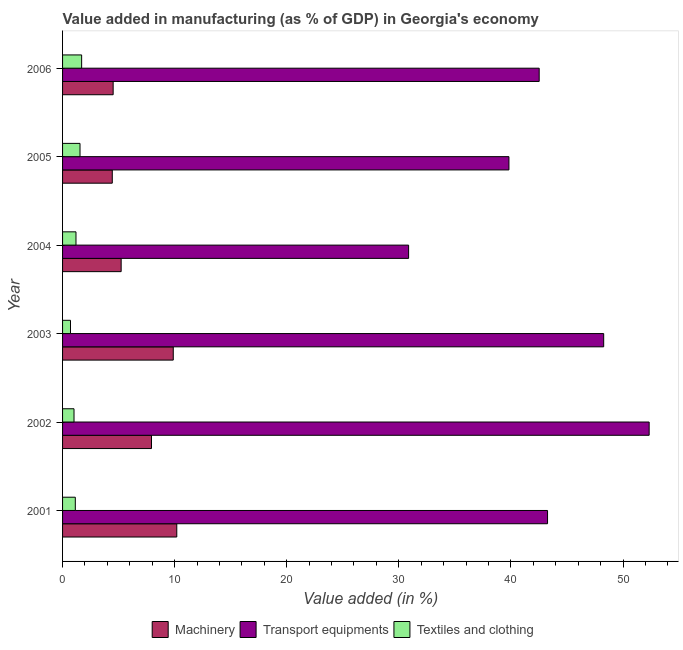How many different coloured bars are there?
Offer a very short reply. 3. How many groups of bars are there?
Your answer should be very brief. 6. Are the number of bars per tick equal to the number of legend labels?
Offer a terse response. Yes. Are the number of bars on each tick of the Y-axis equal?
Offer a terse response. Yes. What is the label of the 2nd group of bars from the top?
Ensure brevity in your answer.  2005. In how many cases, is the number of bars for a given year not equal to the number of legend labels?
Your answer should be very brief. 0. What is the value added in manufacturing textile and clothing in 2006?
Give a very brief answer. 1.7. Across all years, what is the maximum value added in manufacturing textile and clothing?
Ensure brevity in your answer.  1.7. Across all years, what is the minimum value added in manufacturing machinery?
Make the answer very short. 4.44. What is the total value added in manufacturing textile and clothing in the graph?
Provide a short and direct response. 7.32. What is the difference between the value added in manufacturing machinery in 2005 and that in 2006?
Give a very brief answer. -0.08. What is the difference between the value added in manufacturing textile and clothing in 2004 and the value added in manufacturing machinery in 2005?
Provide a short and direct response. -3.24. What is the average value added in manufacturing machinery per year?
Provide a short and direct response. 7.03. In the year 2003, what is the difference between the value added in manufacturing textile and clothing and value added in manufacturing transport equipments?
Provide a short and direct response. -47.57. What is the ratio of the value added in manufacturing textile and clothing in 2001 to that in 2003?
Offer a terse response. 1.61. What is the difference between the highest and the second highest value added in manufacturing transport equipments?
Your response must be concise. 4.06. What is the difference between the highest and the lowest value added in manufacturing transport equipments?
Your response must be concise. 21.46. In how many years, is the value added in manufacturing transport equipments greater than the average value added in manufacturing transport equipments taken over all years?
Ensure brevity in your answer.  3. Is the sum of the value added in manufacturing machinery in 2003 and 2004 greater than the maximum value added in manufacturing transport equipments across all years?
Your answer should be very brief. No. What does the 2nd bar from the top in 2004 represents?
Keep it short and to the point. Transport equipments. What does the 3rd bar from the bottom in 2005 represents?
Give a very brief answer. Textiles and clothing. How many years are there in the graph?
Keep it short and to the point. 6. Does the graph contain any zero values?
Keep it short and to the point. No. Does the graph contain grids?
Keep it short and to the point. No. Where does the legend appear in the graph?
Give a very brief answer. Bottom center. How are the legend labels stacked?
Provide a short and direct response. Horizontal. What is the title of the graph?
Keep it short and to the point. Value added in manufacturing (as % of GDP) in Georgia's economy. Does "Grants" appear as one of the legend labels in the graph?
Ensure brevity in your answer.  No. What is the label or title of the X-axis?
Make the answer very short. Value added (in %). What is the Value added (in %) in Machinery in 2001?
Ensure brevity in your answer.  10.19. What is the Value added (in %) of Transport equipments in 2001?
Make the answer very short. 43.27. What is the Value added (in %) in Textiles and clothing in 2001?
Offer a very short reply. 1.14. What is the Value added (in %) in Machinery in 2002?
Offer a very short reply. 7.93. What is the Value added (in %) of Transport equipments in 2002?
Offer a very short reply. 52.33. What is the Value added (in %) of Textiles and clothing in 2002?
Provide a short and direct response. 1.02. What is the Value added (in %) of Machinery in 2003?
Offer a terse response. 9.88. What is the Value added (in %) in Transport equipments in 2003?
Ensure brevity in your answer.  48.28. What is the Value added (in %) of Textiles and clothing in 2003?
Keep it short and to the point. 0.71. What is the Value added (in %) in Machinery in 2004?
Make the answer very short. 5.23. What is the Value added (in %) of Transport equipments in 2004?
Your answer should be very brief. 30.87. What is the Value added (in %) in Textiles and clothing in 2004?
Make the answer very short. 1.2. What is the Value added (in %) of Machinery in 2005?
Provide a short and direct response. 4.44. What is the Value added (in %) in Transport equipments in 2005?
Your response must be concise. 39.82. What is the Value added (in %) in Textiles and clothing in 2005?
Your answer should be very brief. 1.56. What is the Value added (in %) in Machinery in 2006?
Offer a terse response. 4.51. What is the Value added (in %) of Transport equipments in 2006?
Offer a very short reply. 42.52. What is the Value added (in %) of Textiles and clothing in 2006?
Give a very brief answer. 1.7. Across all years, what is the maximum Value added (in %) of Machinery?
Offer a very short reply. 10.19. Across all years, what is the maximum Value added (in %) of Transport equipments?
Ensure brevity in your answer.  52.33. Across all years, what is the maximum Value added (in %) in Textiles and clothing?
Your response must be concise. 1.7. Across all years, what is the minimum Value added (in %) of Machinery?
Your answer should be compact. 4.44. Across all years, what is the minimum Value added (in %) in Transport equipments?
Provide a short and direct response. 30.87. Across all years, what is the minimum Value added (in %) of Textiles and clothing?
Ensure brevity in your answer.  0.71. What is the total Value added (in %) in Machinery in the graph?
Give a very brief answer. 42.18. What is the total Value added (in %) of Transport equipments in the graph?
Provide a short and direct response. 257.1. What is the total Value added (in %) of Textiles and clothing in the graph?
Ensure brevity in your answer.  7.32. What is the difference between the Value added (in %) in Machinery in 2001 and that in 2002?
Keep it short and to the point. 2.26. What is the difference between the Value added (in %) of Transport equipments in 2001 and that in 2002?
Give a very brief answer. -9.07. What is the difference between the Value added (in %) in Textiles and clothing in 2001 and that in 2002?
Make the answer very short. 0.12. What is the difference between the Value added (in %) of Machinery in 2001 and that in 2003?
Ensure brevity in your answer.  0.31. What is the difference between the Value added (in %) of Transport equipments in 2001 and that in 2003?
Give a very brief answer. -5.01. What is the difference between the Value added (in %) of Textiles and clothing in 2001 and that in 2003?
Offer a very short reply. 0.43. What is the difference between the Value added (in %) in Machinery in 2001 and that in 2004?
Keep it short and to the point. 4.96. What is the difference between the Value added (in %) in Transport equipments in 2001 and that in 2004?
Ensure brevity in your answer.  12.4. What is the difference between the Value added (in %) of Textiles and clothing in 2001 and that in 2004?
Offer a terse response. -0.06. What is the difference between the Value added (in %) of Machinery in 2001 and that in 2005?
Offer a terse response. 5.75. What is the difference between the Value added (in %) of Transport equipments in 2001 and that in 2005?
Keep it short and to the point. 3.44. What is the difference between the Value added (in %) of Textiles and clothing in 2001 and that in 2005?
Keep it short and to the point. -0.42. What is the difference between the Value added (in %) of Machinery in 2001 and that in 2006?
Make the answer very short. 5.68. What is the difference between the Value added (in %) of Transport equipments in 2001 and that in 2006?
Ensure brevity in your answer.  0.75. What is the difference between the Value added (in %) in Textiles and clothing in 2001 and that in 2006?
Provide a short and direct response. -0.56. What is the difference between the Value added (in %) of Machinery in 2002 and that in 2003?
Give a very brief answer. -1.94. What is the difference between the Value added (in %) in Transport equipments in 2002 and that in 2003?
Provide a short and direct response. 4.06. What is the difference between the Value added (in %) in Textiles and clothing in 2002 and that in 2003?
Your answer should be very brief. 0.31. What is the difference between the Value added (in %) of Machinery in 2002 and that in 2004?
Your answer should be very brief. 2.71. What is the difference between the Value added (in %) in Transport equipments in 2002 and that in 2004?
Your answer should be compact. 21.46. What is the difference between the Value added (in %) in Textiles and clothing in 2002 and that in 2004?
Keep it short and to the point. -0.18. What is the difference between the Value added (in %) of Machinery in 2002 and that in 2005?
Give a very brief answer. 3.5. What is the difference between the Value added (in %) in Transport equipments in 2002 and that in 2005?
Your answer should be very brief. 12.51. What is the difference between the Value added (in %) in Textiles and clothing in 2002 and that in 2005?
Make the answer very short. -0.54. What is the difference between the Value added (in %) in Machinery in 2002 and that in 2006?
Your answer should be compact. 3.42. What is the difference between the Value added (in %) of Transport equipments in 2002 and that in 2006?
Offer a very short reply. 9.81. What is the difference between the Value added (in %) of Textiles and clothing in 2002 and that in 2006?
Offer a very short reply. -0.68. What is the difference between the Value added (in %) of Machinery in 2003 and that in 2004?
Keep it short and to the point. 4.65. What is the difference between the Value added (in %) in Transport equipments in 2003 and that in 2004?
Offer a terse response. 17.4. What is the difference between the Value added (in %) in Textiles and clothing in 2003 and that in 2004?
Offer a terse response. -0.49. What is the difference between the Value added (in %) in Machinery in 2003 and that in 2005?
Ensure brevity in your answer.  5.44. What is the difference between the Value added (in %) in Transport equipments in 2003 and that in 2005?
Offer a very short reply. 8.45. What is the difference between the Value added (in %) of Textiles and clothing in 2003 and that in 2005?
Offer a terse response. -0.85. What is the difference between the Value added (in %) of Machinery in 2003 and that in 2006?
Keep it short and to the point. 5.36. What is the difference between the Value added (in %) in Transport equipments in 2003 and that in 2006?
Your answer should be very brief. 5.75. What is the difference between the Value added (in %) in Textiles and clothing in 2003 and that in 2006?
Your answer should be very brief. -0.99. What is the difference between the Value added (in %) in Machinery in 2004 and that in 2005?
Keep it short and to the point. 0.79. What is the difference between the Value added (in %) in Transport equipments in 2004 and that in 2005?
Ensure brevity in your answer.  -8.95. What is the difference between the Value added (in %) in Textiles and clothing in 2004 and that in 2005?
Offer a terse response. -0.36. What is the difference between the Value added (in %) in Machinery in 2004 and that in 2006?
Provide a succinct answer. 0.71. What is the difference between the Value added (in %) in Transport equipments in 2004 and that in 2006?
Keep it short and to the point. -11.65. What is the difference between the Value added (in %) of Textiles and clothing in 2004 and that in 2006?
Provide a succinct answer. -0.51. What is the difference between the Value added (in %) of Machinery in 2005 and that in 2006?
Provide a succinct answer. -0.08. What is the difference between the Value added (in %) of Transport equipments in 2005 and that in 2006?
Give a very brief answer. -2.7. What is the difference between the Value added (in %) of Textiles and clothing in 2005 and that in 2006?
Provide a succinct answer. -0.15. What is the difference between the Value added (in %) in Machinery in 2001 and the Value added (in %) in Transport equipments in 2002?
Keep it short and to the point. -42.14. What is the difference between the Value added (in %) of Machinery in 2001 and the Value added (in %) of Textiles and clothing in 2002?
Provide a succinct answer. 9.17. What is the difference between the Value added (in %) of Transport equipments in 2001 and the Value added (in %) of Textiles and clothing in 2002?
Make the answer very short. 42.25. What is the difference between the Value added (in %) of Machinery in 2001 and the Value added (in %) of Transport equipments in 2003?
Keep it short and to the point. -38.09. What is the difference between the Value added (in %) of Machinery in 2001 and the Value added (in %) of Textiles and clothing in 2003?
Keep it short and to the point. 9.48. What is the difference between the Value added (in %) of Transport equipments in 2001 and the Value added (in %) of Textiles and clothing in 2003?
Your answer should be very brief. 42.56. What is the difference between the Value added (in %) of Machinery in 2001 and the Value added (in %) of Transport equipments in 2004?
Make the answer very short. -20.68. What is the difference between the Value added (in %) in Machinery in 2001 and the Value added (in %) in Textiles and clothing in 2004?
Give a very brief answer. 8.99. What is the difference between the Value added (in %) of Transport equipments in 2001 and the Value added (in %) of Textiles and clothing in 2004?
Provide a succinct answer. 42.07. What is the difference between the Value added (in %) in Machinery in 2001 and the Value added (in %) in Transport equipments in 2005?
Provide a short and direct response. -29.63. What is the difference between the Value added (in %) of Machinery in 2001 and the Value added (in %) of Textiles and clothing in 2005?
Give a very brief answer. 8.63. What is the difference between the Value added (in %) in Transport equipments in 2001 and the Value added (in %) in Textiles and clothing in 2005?
Your answer should be compact. 41.71. What is the difference between the Value added (in %) of Machinery in 2001 and the Value added (in %) of Transport equipments in 2006?
Your answer should be very brief. -32.33. What is the difference between the Value added (in %) of Machinery in 2001 and the Value added (in %) of Textiles and clothing in 2006?
Your response must be concise. 8.49. What is the difference between the Value added (in %) of Transport equipments in 2001 and the Value added (in %) of Textiles and clothing in 2006?
Your answer should be very brief. 41.57. What is the difference between the Value added (in %) in Machinery in 2002 and the Value added (in %) in Transport equipments in 2003?
Your answer should be very brief. -40.34. What is the difference between the Value added (in %) in Machinery in 2002 and the Value added (in %) in Textiles and clothing in 2003?
Offer a very short reply. 7.23. What is the difference between the Value added (in %) in Transport equipments in 2002 and the Value added (in %) in Textiles and clothing in 2003?
Provide a short and direct response. 51.63. What is the difference between the Value added (in %) in Machinery in 2002 and the Value added (in %) in Transport equipments in 2004?
Make the answer very short. -22.94. What is the difference between the Value added (in %) in Machinery in 2002 and the Value added (in %) in Textiles and clothing in 2004?
Make the answer very short. 6.74. What is the difference between the Value added (in %) in Transport equipments in 2002 and the Value added (in %) in Textiles and clothing in 2004?
Your response must be concise. 51.14. What is the difference between the Value added (in %) of Machinery in 2002 and the Value added (in %) of Transport equipments in 2005?
Your response must be concise. -31.89. What is the difference between the Value added (in %) of Machinery in 2002 and the Value added (in %) of Textiles and clothing in 2005?
Your answer should be compact. 6.38. What is the difference between the Value added (in %) in Transport equipments in 2002 and the Value added (in %) in Textiles and clothing in 2005?
Offer a terse response. 50.78. What is the difference between the Value added (in %) in Machinery in 2002 and the Value added (in %) in Transport equipments in 2006?
Offer a terse response. -34.59. What is the difference between the Value added (in %) of Machinery in 2002 and the Value added (in %) of Textiles and clothing in 2006?
Provide a succinct answer. 6.23. What is the difference between the Value added (in %) of Transport equipments in 2002 and the Value added (in %) of Textiles and clothing in 2006?
Offer a terse response. 50.63. What is the difference between the Value added (in %) in Machinery in 2003 and the Value added (in %) in Transport equipments in 2004?
Your answer should be compact. -21. What is the difference between the Value added (in %) in Machinery in 2003 and the Value added (in %) in Textiles and clothing in 2004?
Your answer should be very brief. 8.68. What is the difference between the Value added (in %) in Transport equipments in 2003 and the Value added (in %) in Textiles and clothing in 2004?
Provide a short and direct response. 47.08. What is the difference between the Value added (in %) in Machinery in 2003 and the Value added (in %) in Transport equipments in 2005?
Offer a very short reply. -29.95. What is the difference between the Value added (in %) of Machinery in 2003 and the Value added (in %) of Textiles and clothing in 2005?
Your answer should be compact. 8.32. What is the difference between the Value added (in %) in Transport equipments in 2003 and the Value added (in %) in Textiles and clothing in 2005?
Offer a terse response. 46.72. What is the difference between the Value added (in %) of Machinery in 2003 and the Value added (in %) of Transport equipments in 2006?
Provide a succinct answer. -32.65. What is the difference between the Value added (in %) in Machinery in 2003 and the Value added (in %) in Textiles and clothing in 2006?
Make the answer very short. 8.17. What is the difference between the Value added (in %) in Transport equipments in 2003 and the Value added (in %) in Textiles and clothing in 2006?
Offer a very short reply. 46.57. What is the difference between the Value added (in %) of Machinery in 2004 and the Value added (in %) of Transport equipments in 2005?
Offer a terse response. -34.6. What is the difference between the Value added (in %) in Machinery in 2004 and the Value added (in %) in Textiles and clothing in 2005?
Give a very brief answer. 3.67. What is the difference between the Value added (in %) of Transport equipments in 2004 and the Value added (in %) of Textiles and clothing in 2005?
Offer a very short reply. 29.32. What is the difference between the Value added (in %) of Machinery in 2004 and the Value added (in %) of Transport equipments in 2006?
Offer a very short reply. -37.29. What is the difference between the Value added (in %) of Machinery in 2004 and the Value added (in %) of Textiles and clothing in 2006?
Your answer should be compact. 3.53. What is the difference between the Value added (in %) of Transport equipments in 2004 and the Value added (in %) of Textiles and clothing in 2006?
Ensure brevity in your answer.  29.17. What is the difference between the Value added (in %) in Machinery in 2005 and the Value added (in %) in Transport equipments in 2006?
Offer a very short reply. -38.09. What is the difference between the Value added (in %) of Machinery in 2005 and the Value added (in %) of Textiles and clothing in 2006?
Your response must be concise. 2.73. What is the difference between the Value added (in %) of Transport equipments in 2005 and the Value added (in %) of Textiles and clothing in 2006?
Offer a terse response. 38.12. What is the average Value added (in %) in Machinery per year?
Give a very brief answer. 7.03. What is the average Value added (in %) of Transport equipments per year?
Make the answer very short. 42.85. What is the average Value added (in %) in Textiles and clothing per year?
Give a very brief answer. 1.22. In the year 2001, what is the difference between the Value added (in %) of Machinery and Value added (in %) of Transport equipments?
Offer a very short reply. -33.08. In the year 2001, what is the difference between the Value added (in %) in Machinery and Value added (in %) in Textiles and clothing?
Offer a terse response. 9.05. In the year 2001, what is the difference between the Value added (in %) in Transport equipments and Value added (in %) in Textiles and clothing?
Keep it short and to the point. 42.13. In the year 2002, what is the difference between the Value added (in %) of Machinery and Value added (in %) of Transport equipments?
Offer a terse response. -44.4. In the year 2002, what is the difference between the Value added (in %) of Machinery and Value added (in %) of Textiles and clothing?
Provide a succinct answer. 6.91. In the year 2002, what is the difference between the Value added (in %) of Transport equipments and Value added (in %) of Textiles and clothing?
Offer a terse response. 51.31. In the year 2003, what is the difference between the Value added (in %) in Machinery and Value added (in %) in Transport equipments?
Provide a succinct answer. -38.4. In the year 2003, what is the difference between the Value added (in %) of Machinery and Value added (in %) of Textiles and clothing?
Your answer should be very brief. 9.17. In the year 2003, what is the difference between the Value added (in %) in Transport equipments and Value added (in %) in Textiles and clothing?
Your response must be concise. 47.57. In the year 2004, what is the difference between the Value added (in %) in Machinery and Value added (in %) in Transport equipments?
Give a very brief answer. -25.65. In the year 2004, what is the difference between the Value added (in %) in Machinery and Value added (in %) in Textiles and clothing?
Keep it short and to the point. 4.03. In the year 2004, what is the difference between the Value added (in %) in Transport equipments and Value added (in %) in Textiles and clothing?
Give a very brief answer. 29.68. In the year 2005, what is the difference between the Value added (in %) of Machinery and Value added (in %) of Transport equipments?
Your answer should be very brief. -35.39. In the year 2005, what is the difference between the Value added (in %) in Machinery and Value added (in %) in Textiles and clothing?
Offer a terse response. 2.88. In the year 2005, what is the difference between the Value added (in %) in Transport equipments and Value added (in %) in Textiles and clothing?
Make the answer very short. 38.27. In the year 2006, what is the difference between the Value added (in %) of Machinery and Value added (in %) of Transport equipments?
Offer a terse response. -38.01. In the year 2006, what is the difference between the Value added (in %) of Machinery and Value added (in %) of Textiles and clothing?
Ensure brevity in your answer.  2.81. In the year 2006, what is the difference between the Value added (in %) in Transport equipments and Value added (in %) in Textiles and clothing?
Provide a short and direct response. 40.82. What is the ratio of the Value added (in %) of Machinery in 2001 to that in 2002?
Keep it short and to the point. 1.28. What is the ratio of the Value added (in %) of Transport equipments in 2001 to that in 2002?
Provide a succinct answer. 0.83. What is the ratio of the Value added (in %) of Textiles and clothing in 2001 to that in 2002?
Offer a terse response. 1.11. What is the ratio of the Value added (in %) in Machinery in 2001 to that in 2003?
Your response must be concise. 1.03. What is the ratio of the Value added (in %) of Transport equipments in 2001 to that in 2003?
Your response must be concise. 0.9. What is the ratio of the Value added (in %) in Textiles and clothing in 2001 to that in 2003?
Your response must be concise. 1.61. What is the ratio of the Value added (in %) in Machinery in 2001 to that in 2004?
Your response must be concise. 1.95. What is the ratio of the Value added (in %) in Transport equipments in 2001 to that in 2004?
Ensure brevity in your answer.  1.4. What is the ratio of the Value added (in %) of Textiles and clothing in 2001 to that in 2004?
Your answer should be compact. 0.95. What is the ratio of the Value added (in %) of Machinery in 2001 to that in 2005?
Offer a terse response. 2.3. What is the ratio of the Value added (in %) of Transport equipments in 2001 to that in 2005?
Provide a succinct answer. 1.09. What is the ratio of the Value added (in %) of Textiles and clothing in 2001 to that in 2005?
Your answer should be very brief. 0.73. What is the ratio of the Value added (in %) of Machinery in 2001 to that in 2006?
Provide a succinct answer. 2.26. What is the ratio of the Value added (in %) of Transport equipments in 2001 to that in 2006?
Your answer should be very brief. 1.02. What is the ratio of the Value added (in %) of Textiles and clothing in 2001 to that in 2006?
Provide a succinct answer. 0.67. What is the ratio of the Value added (in %) in Machinery in 2002 to that in 2003?
Offer a terse response. 0.8. What is the ratio of the Value added (in %) in Transport equipments in 2002 to that in 2003?
Your answer should be very brief. 1.08. What is the ratio of the Value added (in %) in Textiles and clothing in 2002 to that in 2003?
Keep it short and to the point. 1.44. What is the ratio of the Value added (in %) in Machinery in 2002 to that in 2004?
Your answer should be compact. 1.52. What is the ratio of the Value added (in %) of Transport equipments in 2002 to that in 2004?
Your answer should be very brief. 1.7. What is the ratio of the Value added (in %) of Textiles and clothing in 2002 to that in 2004?
Offer a very short reply. 0.85. What is the ratio of the Value added (in %) in Machinery in 2002 to that in 2005?
Make the answer very short. 1.79. What is the ratio of the Value added (in %) of Transport equipments in 2002 to that in 2005?
Ensure brevity in your answer.  1.31. What is the ratio of the Value added (in %) in Textiles and clothing in 2002 to that in 2005?
Make the answer very short. 0.66. What is the ratio of the Value added (in %) in Machinery in 2002 to that in 2006?
Make the answer very short. 1.76. What is the ratio of the Value added (in %) of Transport equipments in 2002 to that in 2006?
Your answer should be very brief. 1.23. What is the ratio of the Value added (in %) in Textiles and clothing in 2002 to that in 2006?
Offer a very short reply. 0.6. What is the ratio of the Value added (in %) of Machinery in 2003 to that in 2004?
Ensure brevity in your answer.  1.89. What is the ratio of the Value added (in %) of Transport equipments in 2003 to that in 2004?
Ensure brevity in your answer.  1.56. What is the ratio of the Value added (in %) of Textiles and clothing in 2003 to that in 2004?
Provide a short and direct response. 0.59. What is the ratio of the Value added (in %) of Machinery in 2003 to that in 2005?
Keep it short and to the point. 2.23. What is the ratio of the Value added (in %) in Transport equipments in 2003 to that in 2005?
Your answer should be compact. 1.21. What is the ratio of the Value added (in %) of Textiles and clothing in 2003 to that in 2005?
Offer a terse response. 0.45. What is the ratio of the Value added (in %) of Machinery in 2003 to that in 2006?
Give a very brief answer. 2.19. What is the ratio of the Value added (in %) in Transport equipments in 2003 to that in 2006?
Provide a short and direct response. 1.14. What is the ratio of the Value added (in %) in Textiles and clothing in 2003 to that in 2006?
Ensure brevity in your answer.  0.42. What is the ratio of the Value added (in %) in Machinery in 2004 to that in 2005?
Provide a succinct answer. 1.18. What is the ratio of the Value added (in %) in Transport equipments in 2004 to that in 2005?
Give a very brief answer. 0.78. What is the ratio of the Value added (in %) in Textiles and clothing in 2004 to that in 2005?
Offer a terse response. 0.77. What is the ratio of the Value added (in %) of Machinery in 2004 to that in 2006?
Offer a terse response. 1.16. What is the ratio of the Value added (in %) of Transport equipments in 2004 to that in 2006?
Provide a succinct answer. 0.73. What is the ratio of the Value added (in %) of Textiles and clothing in 2004 to that in 2006?
Provide a succinct answer. 0.7. What is the ratio of the Value added (in %) of Machinery in 2005 to that in 2006?
Your answer should be compact. 0.98. What is the ratio of the Value added (in %) of Transport equipments in 2005 to that in 2006?
Your answer should be compact. 0.94. What is the ratio of the Value added (in %) of Textiles and clothing in 2005 to that in 2006?
Make the answer very short. 0.91. What is the difference between the highest and the second highest Value added (in %) in Machinery?
Your answer should be very brief. 0.31. What is the difference between the highest and the second highest Value added (in %) of Transport equipments?
Your answer should be compact. 4.06. What is the difference between the highest and the second highest Value added (in %) in Textiles and clothing?
Make the answer very short. 0.15. What is the difference between the highest and the lowest Value added (in %) in Machinery?
Your answer should be very brief. 5.75. What is the difference between the highest and the lowest Value added (in %) of Transport equipments?
Give a very brief answer. 21.46. 